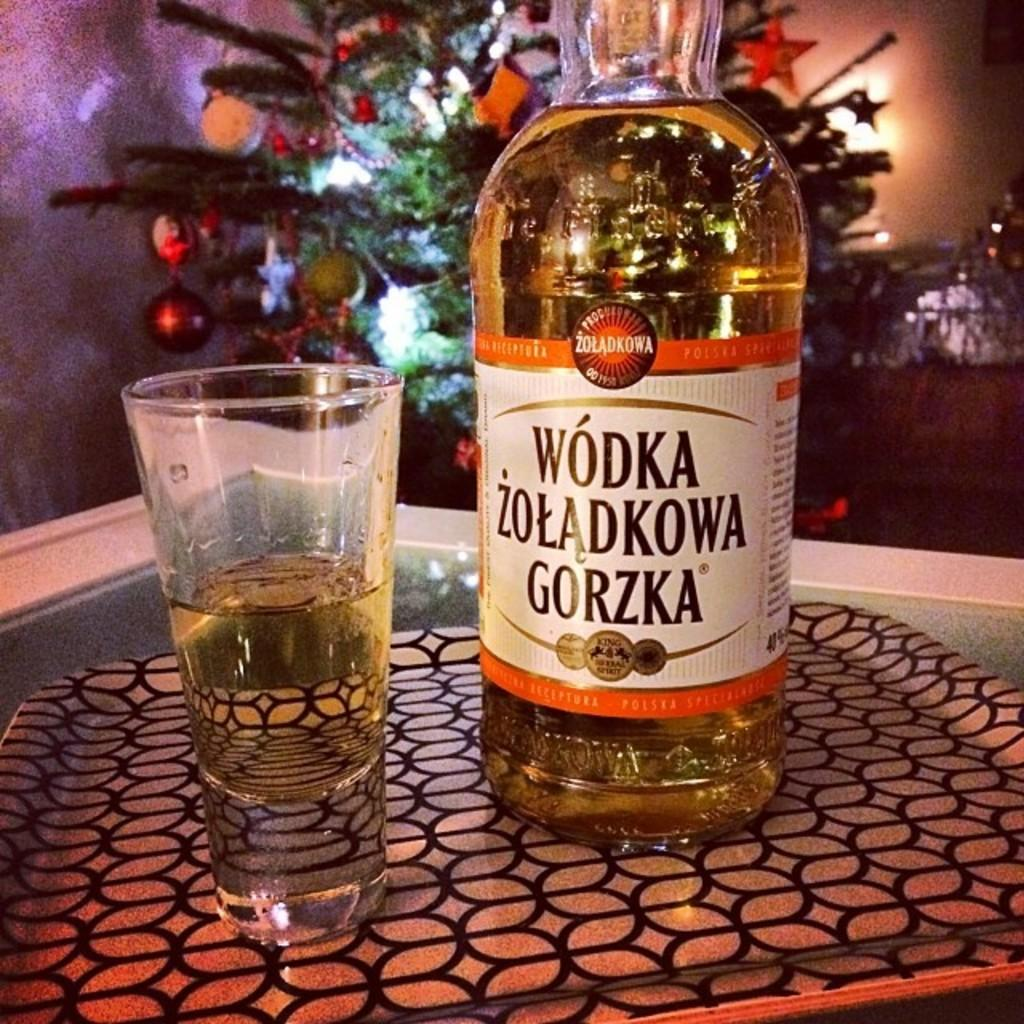<image>
Give a short and clear explanation of the subsequent image. A bottle of Wodka Zoladkowa Gorzka is on the tray. 